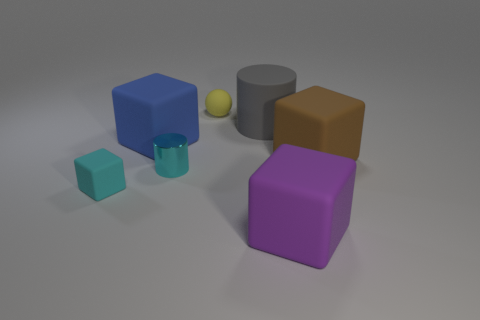Add 1 purple cylinders. How many objects exist? 8 Subtract all cylinders. How many objects are left? 5 Subtract 1 yellow balls. How many objects are left? 6 Subtract all large blue blocks. Subtract all blue rubber things. How many objects are left? 5 Add 2 large blue blocks. How many large blue blocks are left? 3 Add 1 large brown rubber objects. How many large brown rubber objects exist? 2 